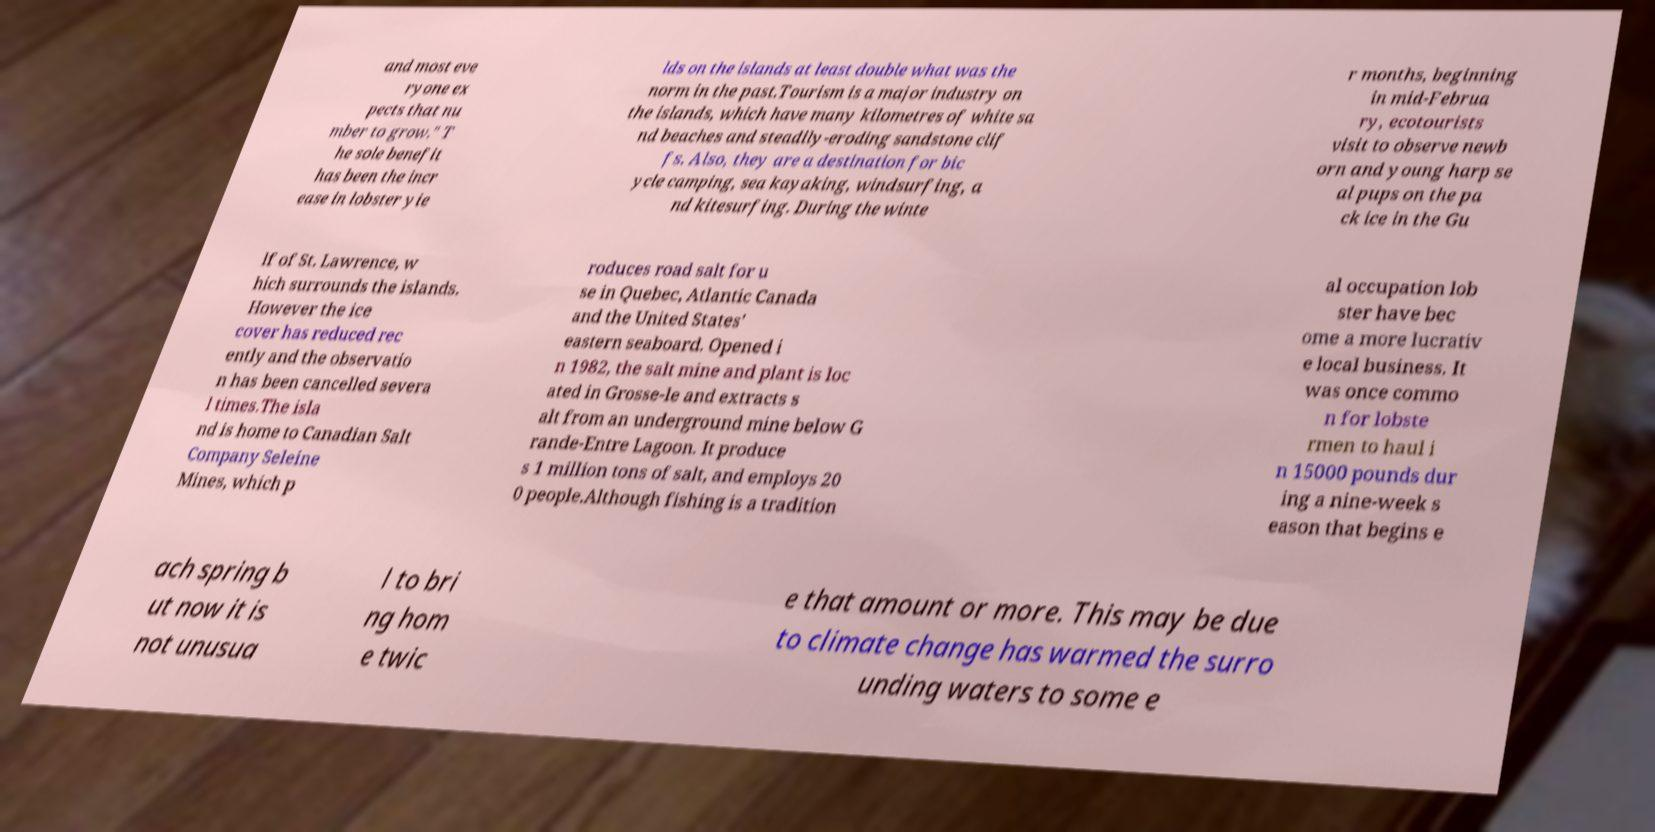Can you accurately transcribe the text from the provided image for me? and most eve ryone ex pects that nu mber to grow." T he sole benefit has been the incr ease in lobster yie lds on the islands at least double what was the norm in the past.Tourism is a major industry on the islands, which have many kilometres of white sa nd beaches and steadily-eroding sandstone clif fs. Also, they are a destination for bic ycle camping, sea kayaking, windsurfing, a nd kitesurfing. During the winte r months, beginning in mid-Februa ry, ecotourists visit to observe newb orn and young harp se al pups on the pa ck ice in the Gu lf of St. Lawrence, w hich surrounds the islands. However the ice cover has reduced rec ently and the observatio n has been cancelled severa l times.The isla nd is home to Canadian Salt Company Seleine Mines, which p roduces road salt for u se in Quebec, Atlantic Canada and the United States' eastern seaboard. Opened i n 1982, the salt mine and plant is loc ated in Grosse-le and extracts s alt from an underground mine below G rande-Entre Lagoon. It produce s 1 million tons of salt, and employs 20 0 people.Although fishing is a tradition al occupation lob ster have bec ome a more lucrativ e local business. It was once commo n for lobste rmen to haul i n 15000 pounds dur ing a nine-week s eason that begins e ach spring b ut now it is not unusua l to bri ng hom e twic e that amount or more. This may be due to climate change has warmed the surro unding waters to some e 